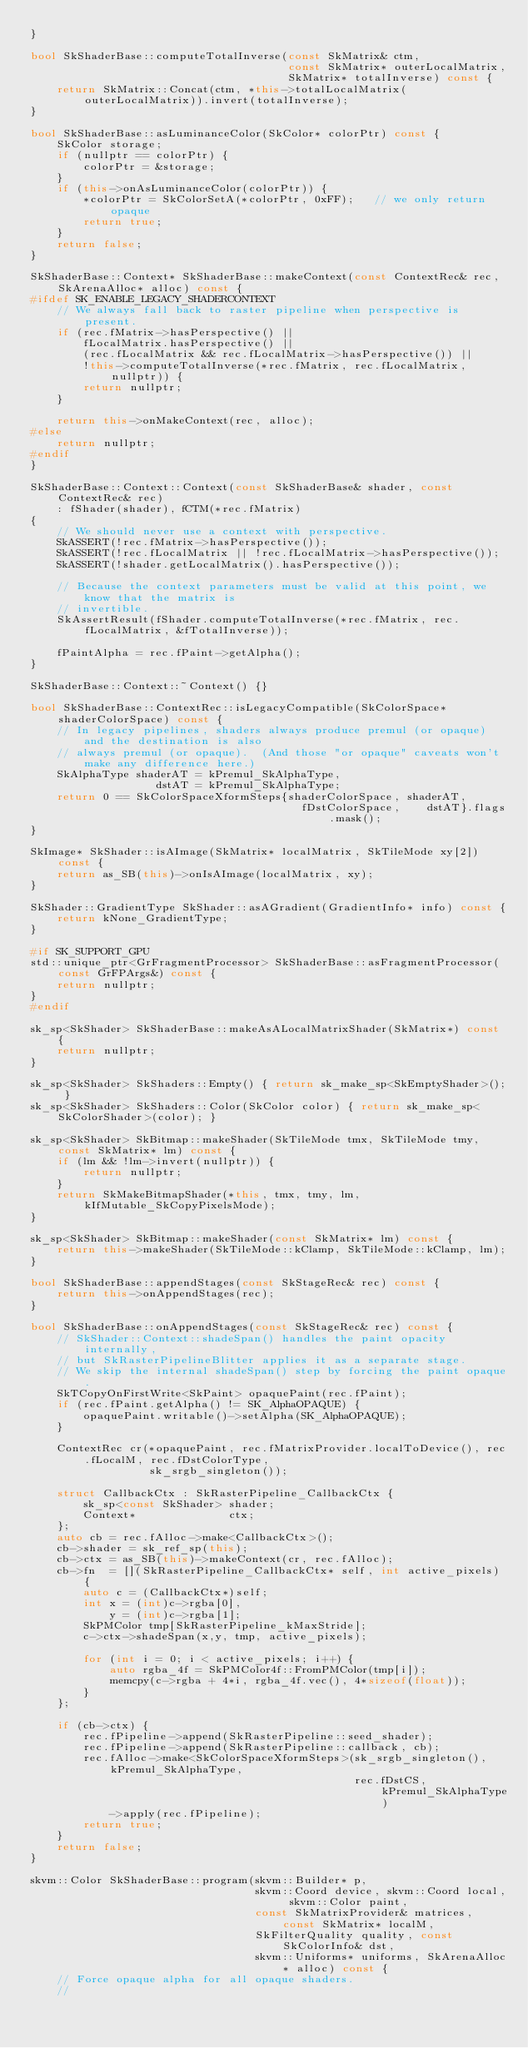Convert code to text. <code><loc_0><loc_0><loc_500><loc_500><_C++_>}

bool SkShaderBase::computeTotalInverse(const SkMatrix& ctm,
                                       const SkMatrix* outerLocalMatrix,
                                       SkMatrix* totalInverse) const {
    return SkMatrix::Concat(ctm, *this->totalLocalMatrix(outerLocalMatrix)).invert(totalInverse);
}

bool SkShaderBase::asLuminanceColor(SkColor* colorPtr) const {
    SkColor storage;
    if (nullptr == colorPtr) {
        colorPtr = &storage;
    }
    if (this->onAsLuminanceColor(colorPtr)) {
        *colorPtr = SkColorSetA(*colorPtr, 0xFF);   // we only return opaque
        return true;
    }
    return false;
}

SkShaderBase::Context* SkShaderBase::makeContext(const ContextRec& rec, SkArenaAlloc* alloc) const {
#ifdef SK_ENABLE_LEGACY_SHADERCONTEXT
    // We always fall back to raster pipeline when perspective is present.
    if (rec.fMatrix->hasPerspective() ||
        fLocalMatrix.hasPerspective() ||
        (rec.fLocalMatrix && rec.fLocalMatrix->hasPerspective()) ||
        !this->computeTotalInverse(*rec.fMatrix, rec.fLocalMatrix, nullptr)) {
        return nullptr;
    }

    return this->onMakeContext(rec, alloc);
#else
    return nullptr;
#endif
}

SkShaderBase::Context::Context(const SkShaderBase& shader, const ContextRec& rec)
    : fShader(shader), fCTM(*rec.fMatrix)
{
    // We should never use a context with perspective.
    SkASSERT(!rec.fMatrix->hasPerspective());
    SkASSERT(!rec.fLocalMatrix || !rec.fLocalMatrix->hasPerspective());
    SkASSERT(!shader.getLocalMatrix().hasPerspective());

    // Because the context parameters must be valid at this point, we know that the matrix is
    // invertible.
    SkAssertResult(fShader.computeTotalInverse(*rec.fMatrix, rec.fLocalMatrix, &fTotalInverse));

    fPaintAlpha = rec.fPaint->getAlpha();
}

SkShaderBase::Context::~Context() {}

bool SkShaderBase::ContextRec::isLegacyCompatible(SkColorSpace* shaderColorSpace) const {
    // In legacy pipelines, shaders always produce premul (or opaque) and the destination is also
    // always premul (or opaque).  (And those "or opaque" caveats won't make any difference here.)
    SkAlphaType shaderAT = kPremul_SkAlphaType,
                   dstAT = kPremul_SkAlphaType;
    return 0 == SkColorSpaceXformSteps{shaderColorSpace, shaderAT,
                                         fDstColorSpace,    dstAT}.flags.mask();
}

SkImage* SkShader::isAImage(SkMatrix* localMatrix, SkTileMode xy[2]) const {
    return as_SB(this)->onIsAImage(localMatrix, xy);
}

SkShader::GradientType SkShader::asAGradient(GradientInfo* info) const {
    return kNone_GradientType;
}

#if SK_SUPPORT_GPU
std::unique_ptr<GrFragmentProcessor> SkShaderBase::asFragmentProcessor(const GrFPArgs&) const {
    return nullptr;
}
#endif

sk_sp<SkShader> SkShaderBase::makeAsALocalMatrixShader(SkMatrix*) const {
    return nullptr;
}

sk_sp<SkShader> SkShaders::Empty() { return sk_make_sp<SkEmptyShader>(); }
sk_sp<SkShader> SkShaders::Color(SkColor color) { return sk_make_sp<SkColorShader>(color); }

sk_sp<SkShader> SkBitmap::makeShader(SkTileMode tmx, SkTileMode tmy, const SkMatrix* lm) const {
    if (lm && !lm->invert(nullptr)) {
        return nullptr;
    }
    return SkMakeBitmapShader(*this, tmx, tmy, lm, kIfMutable_SkCopyPixelsMode);
}

sk_sp<SkShader> SkBitmap::makeShader(const SkMatrix* lm) const {
    return this->makeShader(SkTileMode::kClamp, SkTileMode::kClamp, lm);
}

bool SkShaderBase::appendStages(const SkStageRec& rec) const {
    return this->onAppendStages(rec);
}

bool SkShaderBase::onAppendStages(const SkStageRec& rec) const {
    // SkShader::Context::shadeSpan() handles the paint opacity internally,
    // but SkRasterPipelineBlitter applies it as a separate stage.
    // We skip the internal shadeSpan() step by forcing the paint opaque.
    SkTCopyOnFirstWrite<SkPaint> opaquePaint(rec.fPaint);
    if (rec.fPaint.getAlpha() != SK_AlphaOPAQUE) {
        opaquePaint.writable()->setAlpha(SK_AlphaOPAQUE);
    }

    ContextRec cr(*opaquePaint, rec.fMatrixProvider.localToDevice(), rec.fLocalM, rec.fDstColorType,
                  sk_srgb_singleton());

    struct CallbackCtx : SkRasterPipeline_CallbackCtx {
        sk_sp<const SkShader> shader;
        Context*              ctx;
    };
    auto cb = rec.fAlloc->make<CallbackCtx>();
    cb->shader = sk_ref_sp(this);
    cb->ctx = as_SB(this)->makeContext(cr, rec.fAlloc);
    cb->fn  = [](SkRasterPipeline_CallbackCtx* self, int active_pixels) {
        auto c = (CallbackCtx*)self;
        int x = (int)c->rgba[0],
            y = (int)c->rgba[1];
        SkPMColor tmp[SkRasterPipeline_kMaxStride];
        c->ctx->shadeSpan(x,y, tmp, active_pixels);

        for (int i = 0; i < active_pixels; i++) {
            auto rgba_4f = SkPMColor4f::FromPMColor(tmp[i]);
            memcpy(c->rgba + 4*i, rgba_4f.vec(), 4*sizeof(float));
        }
    };

    if (cb->ctx) {
        rec.fPipeline->append(SkRasterPipeline::seed_shader);
        rec.fPipeline->append(SkRasterPipeline::callback, cb);
        rec.fAlloc->make<SkColorSpaceXformSteps>(sk_srgb_singleton(), kPremul_SkAlphaType,
                                                 rec.fDstCS,          kPremul_SkAlphaType)
            ->apply(rec.fPipeline);
        return true;
    }
    return false;
}

skvm::Color SkShaderBase::program(skvm::Builder* p,
                                  skvm::Coord device, skvm::Coord local, skvm::Color paint,
                                  const SkMatrixProvider& matrices, const SkMatrix* localM,
                                  SkFilterQuality quality, const SkColorInfo& dst,
                                  skvm::Uniforms* uniforms, SkArenaAlloc* alloc) const {
    // Force opaque alpha for all opaque shaders.
    //</code> 